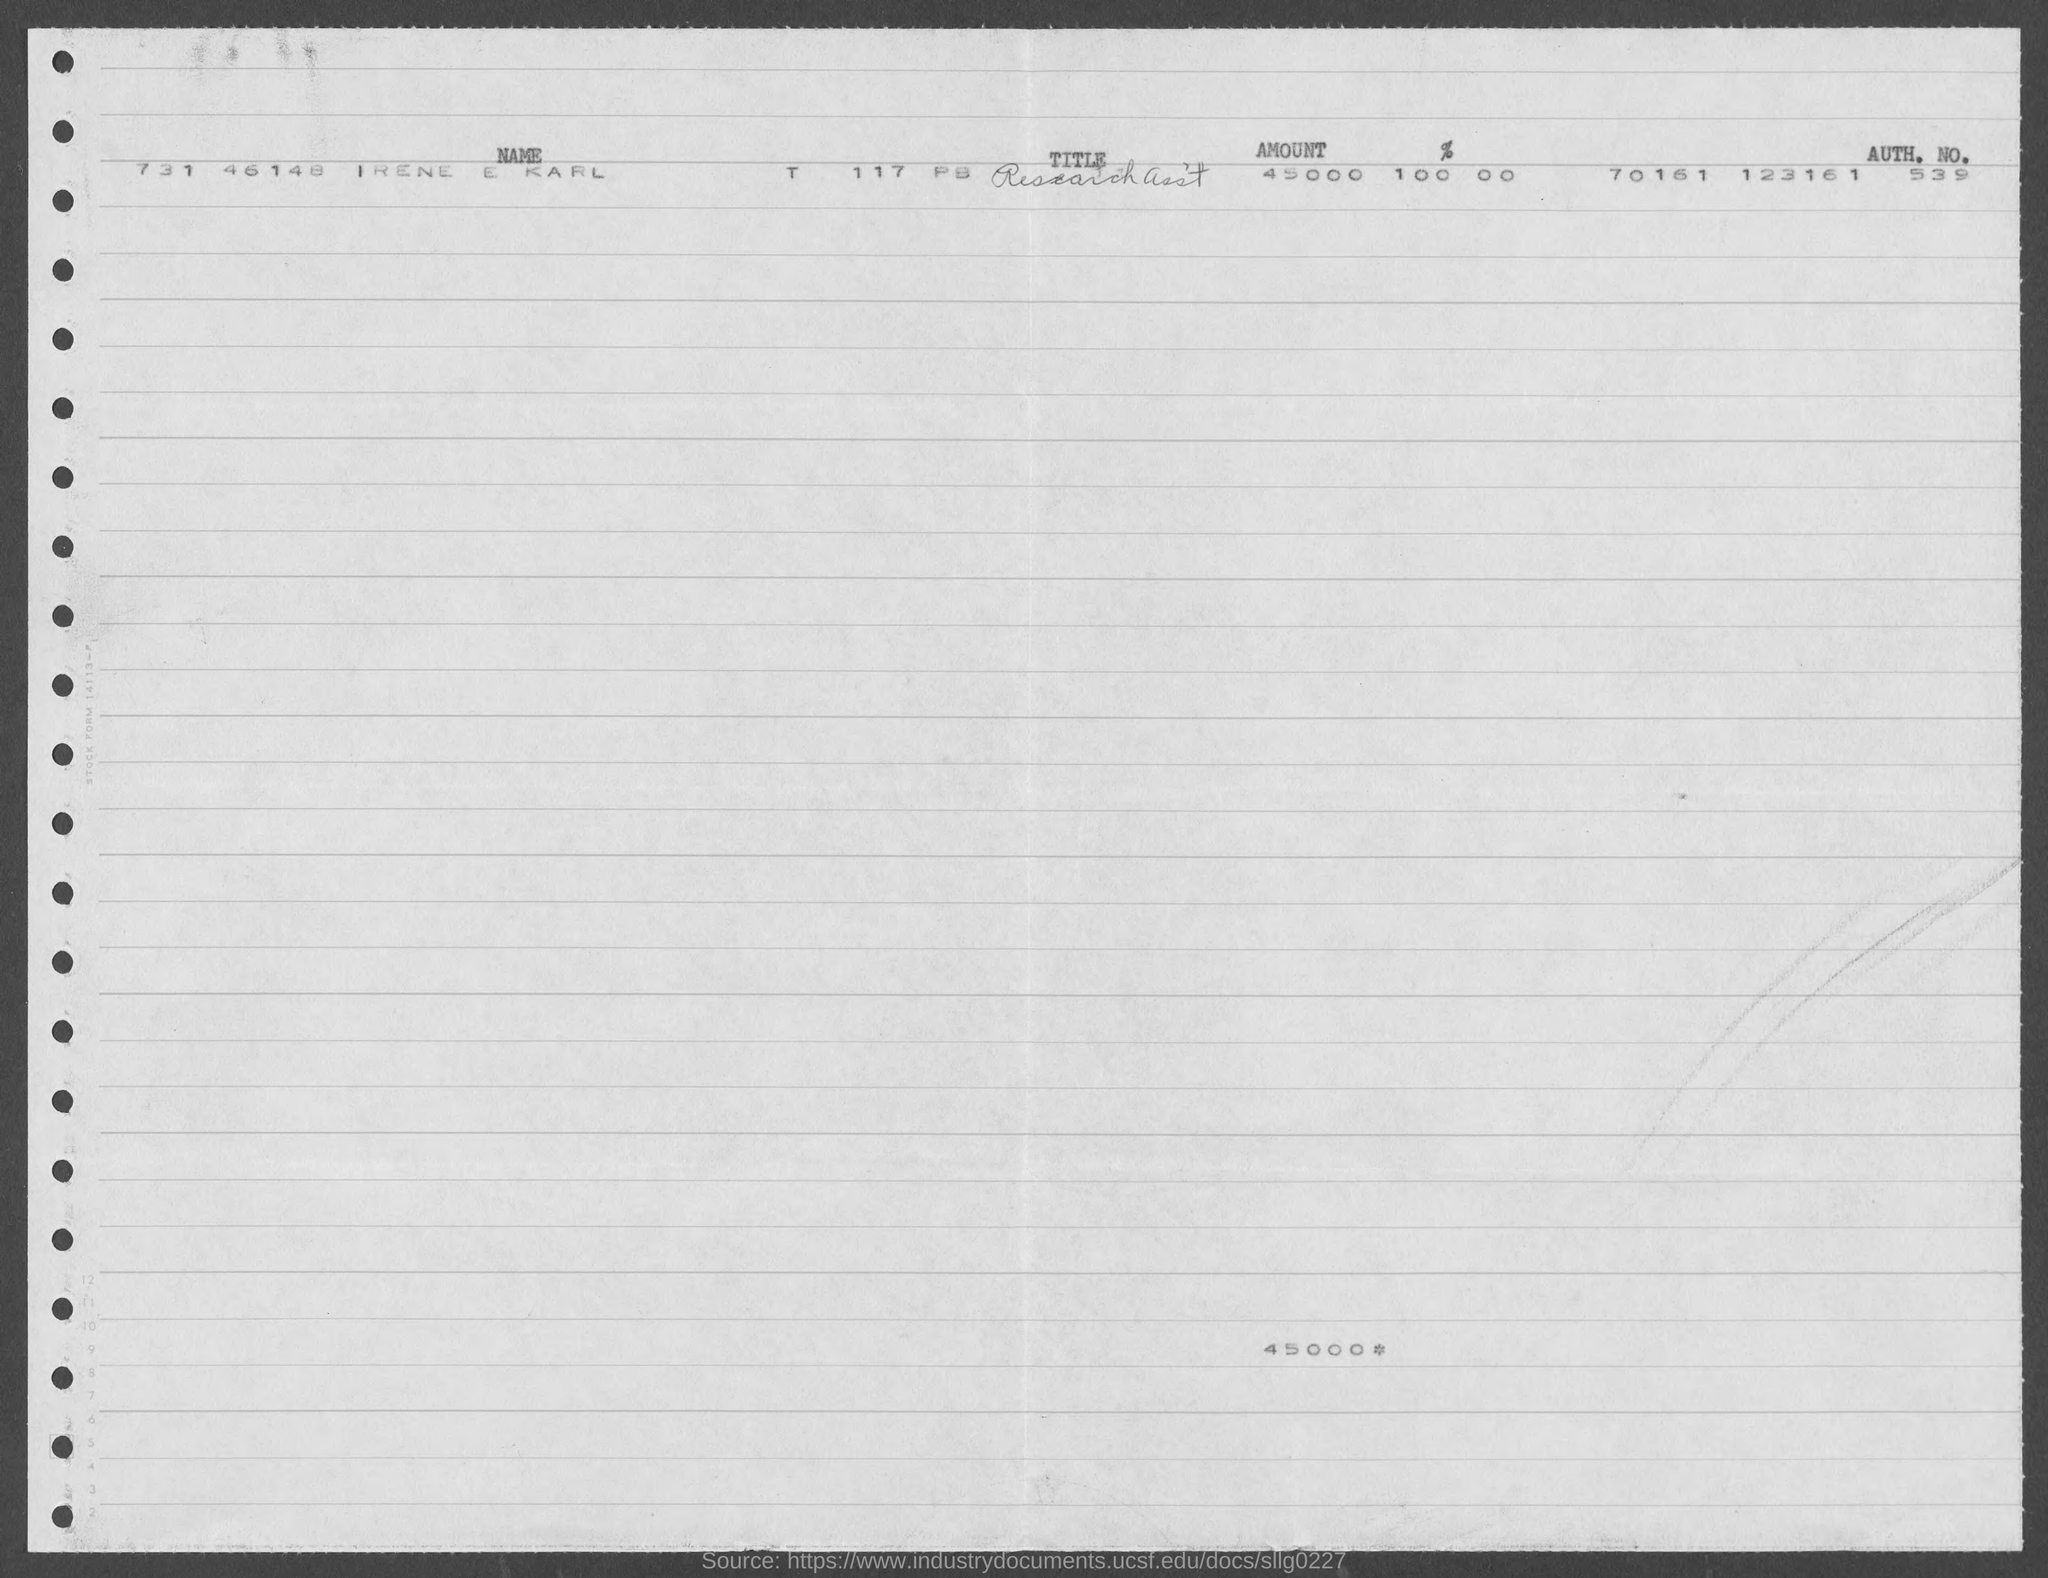What is the amount?
Your answer should be compact. 45000. What is the name of the person?
Your answer should be compact. Irene E Karl. What is the title?
Provide a short and direct response. Research asst. 